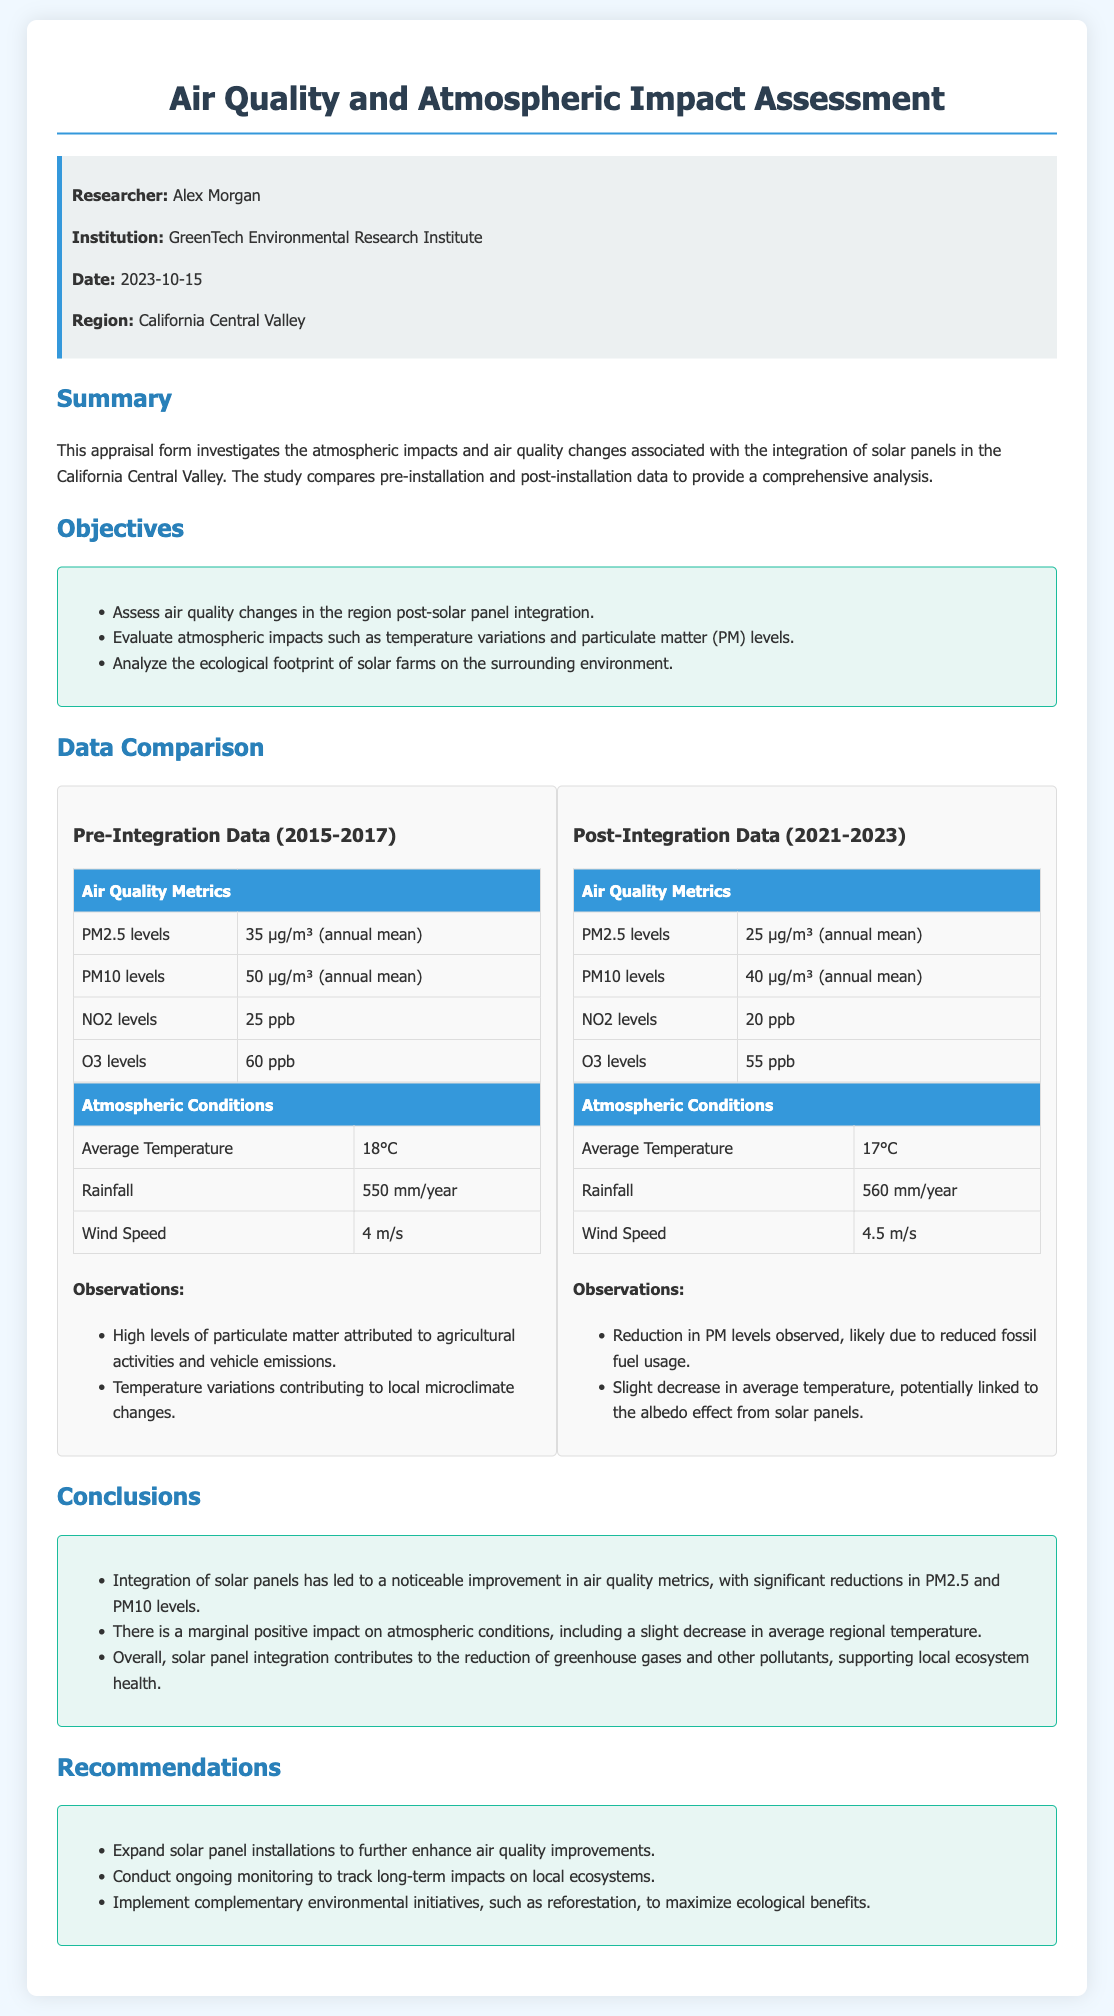What is the name of the researcher? The researcher is named Alex Morgan as stated in the info section.
Answer: Alex Morgan What is the region studied in this assessment? The region is identified as California Central Valley in the info section.
Answer: California Central Valley What are the PM2.5 levels before solar panel integration? The pre-integration PM2.5 levels are mentioned in the Pre-Integration Data table as an annual mean.
Answer: 35 µg/m³ What is the average temperature after solar panel integration? The average temperature post-integration is listed in the Post-Integration Data table.
Answer: 17°C What reduction in PM2.5 levels was observed post-integration? The change in PM2.5 levels post-integration shows a reduction from pre-integration values reported in the document.
Answer: 10 µg/m³ What ecological initiative is recommended for further benefits? The recommendations include implementing environmental initiatives to enhance outcomes.
Answer: Reforestation Which air quality metric showed the largest improvement? The comparison between pre- and post-integration data indicates significant reductions particularly in PM2.5 levels.
Answer: PM2.5 What is the key observation related to temperature after solar panel integration? The findings note a decrease in average temperature linked to the solar panel installation effects described in observations.
Answer: Slight decrease How many years of data were compared in the assessment? The time frames of pre and post-solar panel integration allow us to assess an interval of years.
Answer: 8 years 